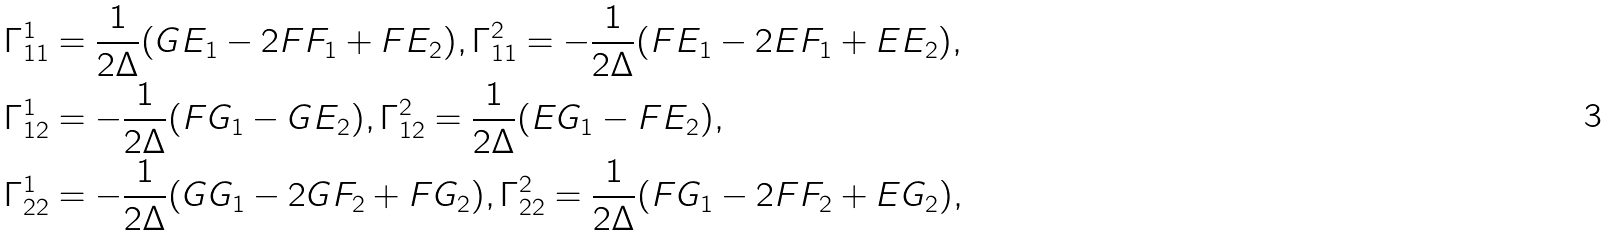<formula> <loc_0><loc_0><loc_500><loc_500>& \Gamma ^ { 1 } _ { 1 1 } = \frac { 1 } { 2 \Delta } ( G E _ { 1 } - 2 F F _ { 1 } + F E _ { 2 } ) , \Gamma ^ { 2 } _ { 1 1 } = - \frac { 1 } { 2 \Delta } ( F E _ { 1 } - 2 E F _ { 1 } + E E _ { 2 } ) , \\ & \Gamma ^ { 1 } _ { 1 2 } = - \frac { 1 } { 2 \Delta } ( F G _ { 1 } - G E _ { 2 } ) , \Gamma ^ { 2 } _ { 1 2 } = \frac { 1 } { 2 \Delta } ( E G _ { 1 } - F E _ { 2 } ) , \\ & \Gamma ^ { 1 } _ { 2 2 } = - \frac { 1 } { 2 \Delta } ( G G _ { 1 } - 2 G F _ { 2 } + F G _ { 2 } ) , \Gamma ^ { 2 } _ { 2 2 } = \frac { 1 } { 2 \Delta } ( F G _ { 1 } - 2 F F _ { 2 } + E G _ { 2 } ) ,</formula> 